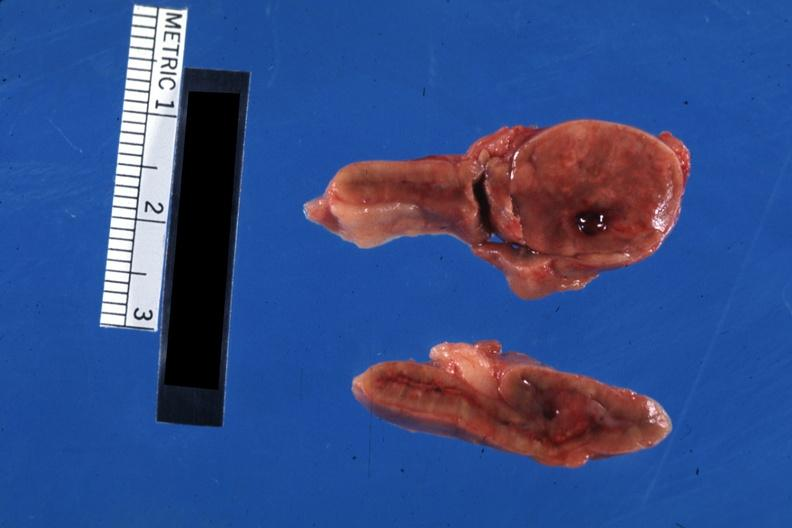what does this image show?
Answer the question using a single word or phrase. Nicely shown single nodule close-up 